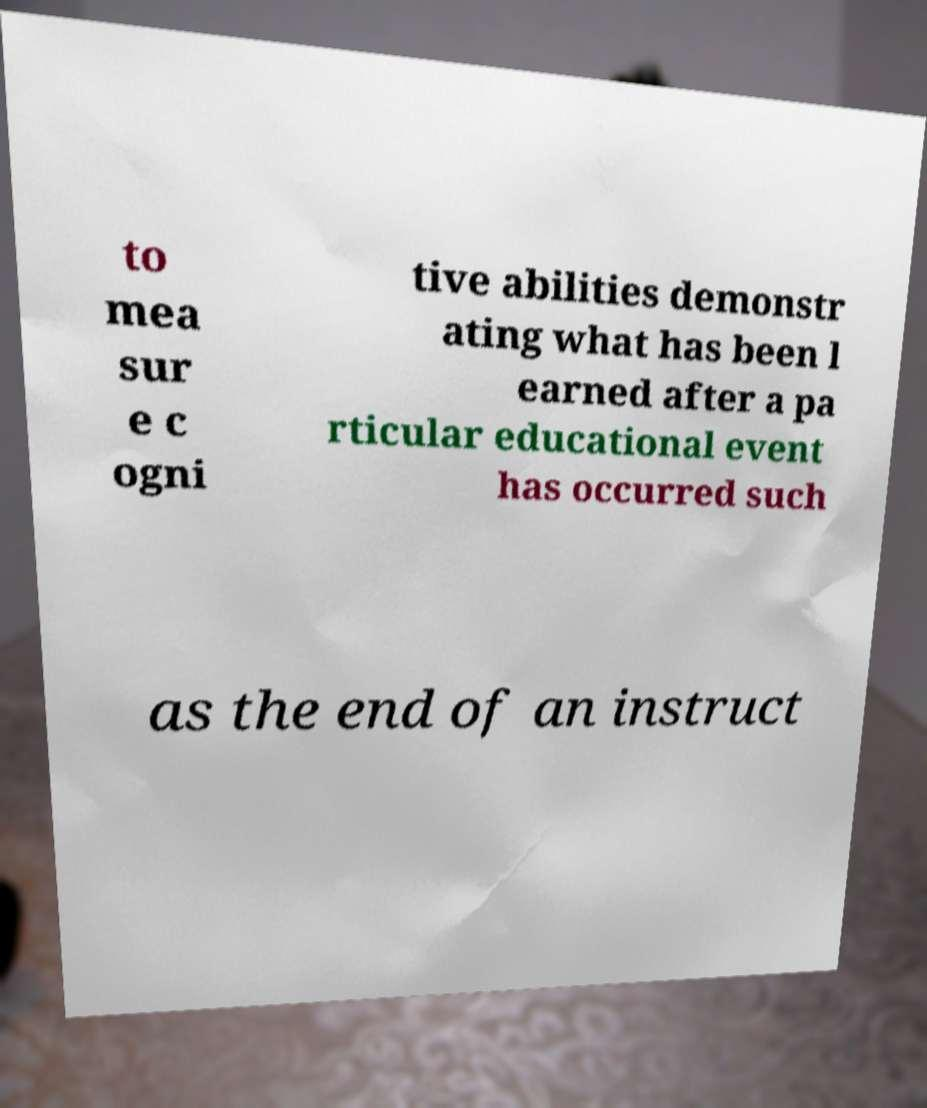Can you accurately transcribe the text from the provided image for me? to mea sur e c ogni tive abilities demonstr ating what has been l earned after a pa rticular educational event has occurred such as the end of an instruct 